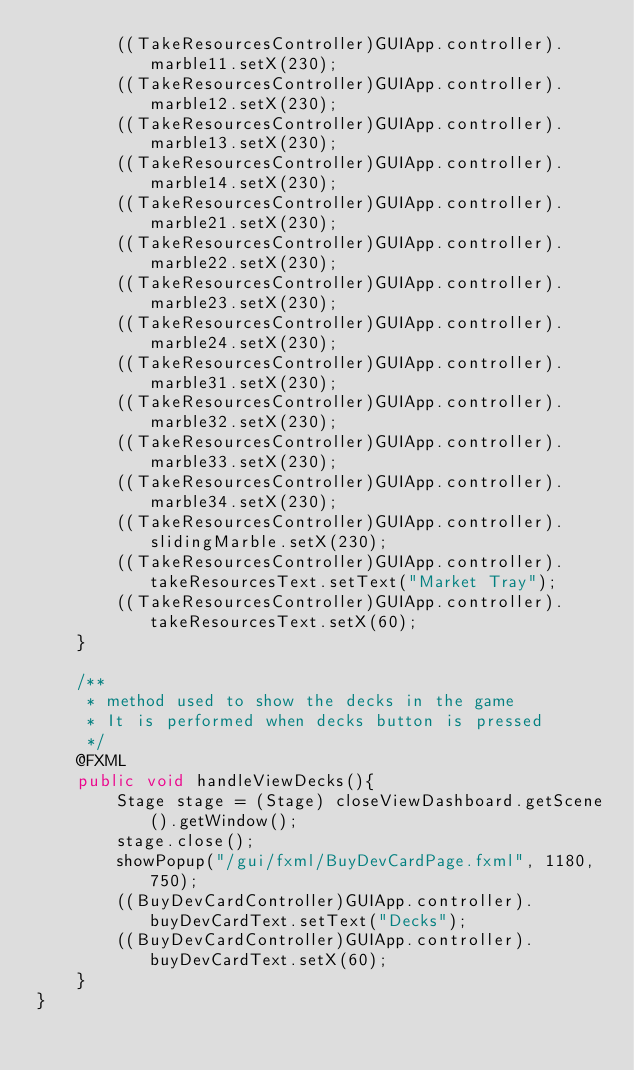<code> <loc_0><loc_0><loc_500><loc_500><_Java_>        ((TakeResourcesController)GUIApp.controller).marble11.setX(230);
        ((TakeResourcesController)GUIApp.controller).marble12.setX(230);
        ((TakeResourcesController)GUIApp.controller).marble13.setX(230);
        ((TakeResourcesController)GUIApp.controller).marble14.setX(230);
        ((TakeResourcesController)GUIApp.controller).marble21.setX(230);
        ((TakeResourcesController)GUIApp.controller).marble22.setX(230);
        ((TakeResourcesController)GUIApp.controller).marble23.setX(230);
        ((TakeResourcesController)GUIApp.controller).marble24.setX(230);
        ((TakeResourcesController)GUIApp.controller).marble31.setX(230);
        ((TakeResourcesController)GUIApp.controller).marble32.setX(230);
        ((TakeResourcesController)GUIApp.controller).marble33.setX(230);
        ((TakeResourcesController)GUIApp.controller).marble34.setX(230);
        ((TakeResourcesController)GUIApp.controller).slidingMarble.setX(230);
        ((TakeResourcesController)GUIApp.controller).takeResourcesText.setText("Market Tray");
        ((TakeResourcesController)GUIApp.controller).takeResourcesText.setX(60);
    }

    /**
     * method used to show the decks in the game
     * It is performed when decks button is pressed
     */
    @FXML
    public void handleViewDecks(){
        Stage stage = (Stage) closeViewDashboard.getScene().getWindow();
        stage.close();
        showPopup("/gui/fxml/BuyDevCardPage.fxml", 1180, 750);
        ((BuyDevCardController)GUIApp.controller).buyDevCardText.setText("Decks");
        ((BuyDevCardController)GUIApp.controller).buyDevCardText.setX(60);
    }
}
</code> 